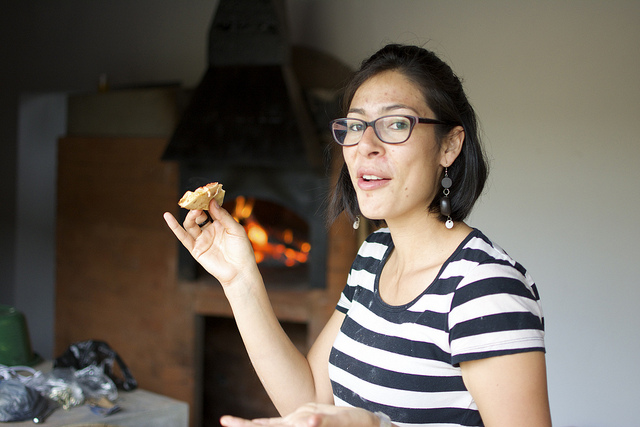<image>What kind of oven is in the background? It is not sure what kind of oven is in the background as it can be a pizza, wood fire, or brick oven. What kind of oven is in the background? I don't know what kind of oven is in the background. It can be a pizza oven, wood fire oven, or a brick oven. 